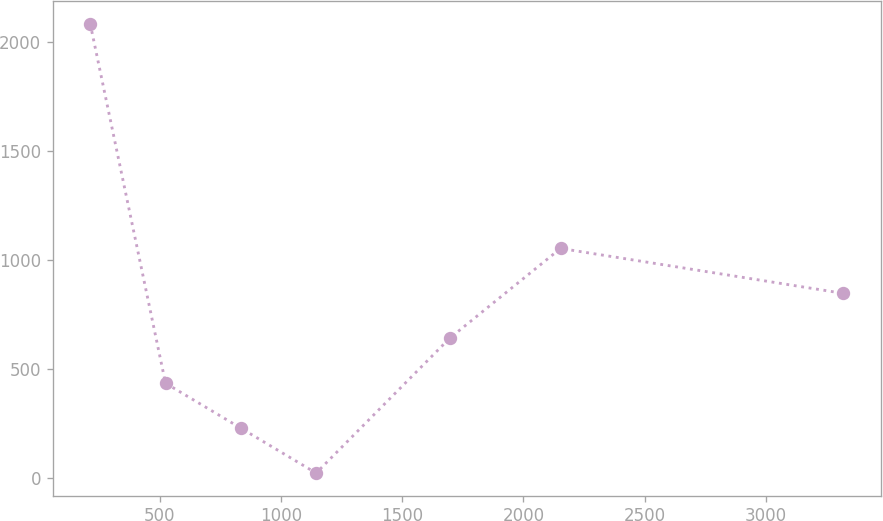Convert chart to OTSL. <chart><loc_0><loc_0><loc_500><loc_500><line_chart><ecel><fcel>Unnamed: 1<nl><fcel>212.78<fcel>2085.06<nl><fcel>523.47<fcel>433.54<nl><fcel>834.16<fcel>227.1<nl><fcel>1144.85<fcel>20.66<nl><fcel>1695.75<fcel>639.98<nl><fcel>2153.35<fcel>1052.86<nl><fcel>3319.72<fcel>846.42<nl></chart> 